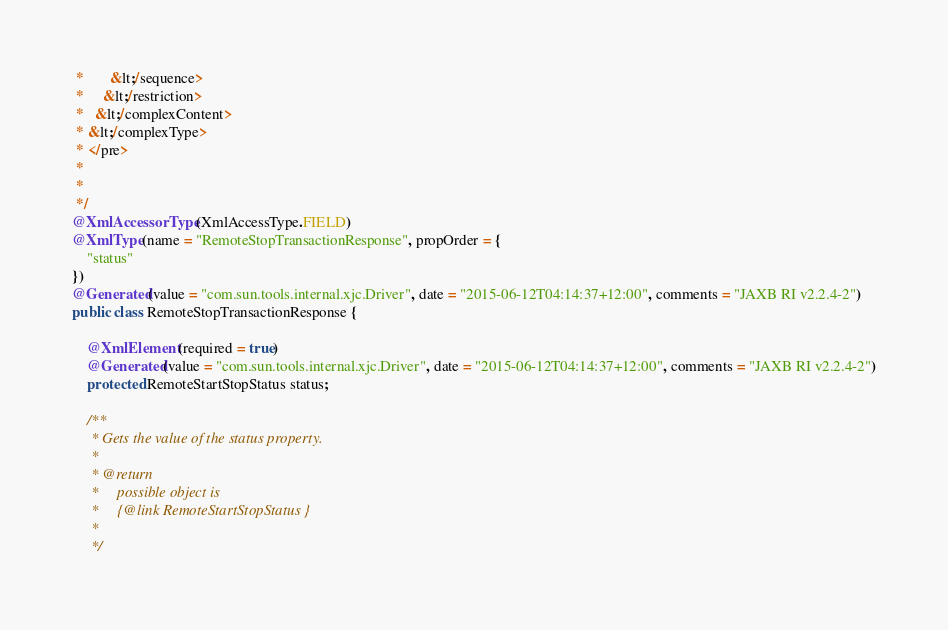Convert code to text. <code><loc_0><loc_0><loc_500><loc_500><_Java_> *       &lt;/sequence>
 *     &lt;/restriction>
 *   &lt;/complexContent>
 * &lt;/complexType>
 * </pre>
 * 
 * 
 */
@XmlAccessorType(XmlAccessType.FIELD)
@XmlType(name = "RemoteStopTransactionResponse", propOrder = {
    "status"
})
@Generated(value = "com.sun.tools.internal.xjc.Driver", date = "2015-06-12T04:14:37+12:00", comments = "JAXB RI v2.2.4-2")
public class RemoteStopTransactionResponse {

    @XmlElement(required = true)
    @Generated(value = "com.sun.tools.internal.xjc.Driver", date = "2015-06-12T04:14:37+12:00", comments = "JAXB RI v2.2.4-2")
    protected RemoteStartStopStatus status;

    /**
     * Gets the value of the status property.
     * 
     * @return
     *     possible object is
     *     {@link RemoteStartStopStatus }
     *     
     */</code> 